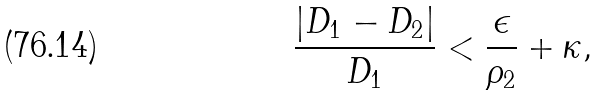Convert formula to latex. <formula><loc_0><loc_0><loc_500><loc_500>\frac { \left | D _ { 1 } - D _ { 2 } \right | } { D _ { 1 } } < \frac { \epsilon } { \rho _ { 2 } } + \kappa ,</formula> 